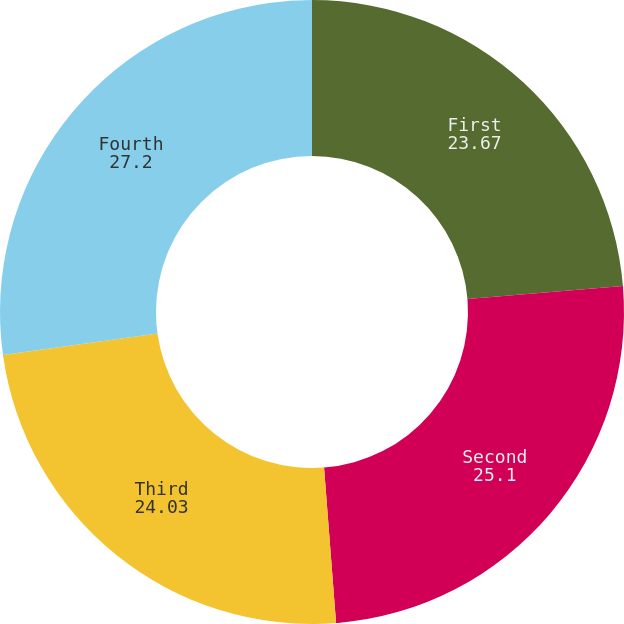<chart> <loc_0><loc_0><loc_500><loc_500><pie_chart><fcel>First<fcel>Second<fcel>Third<fcel>Fourth<nl><fcel>23.67%<fcel>25.1%<fcel>24.03%<fcel>27.2%<nl></chart> 